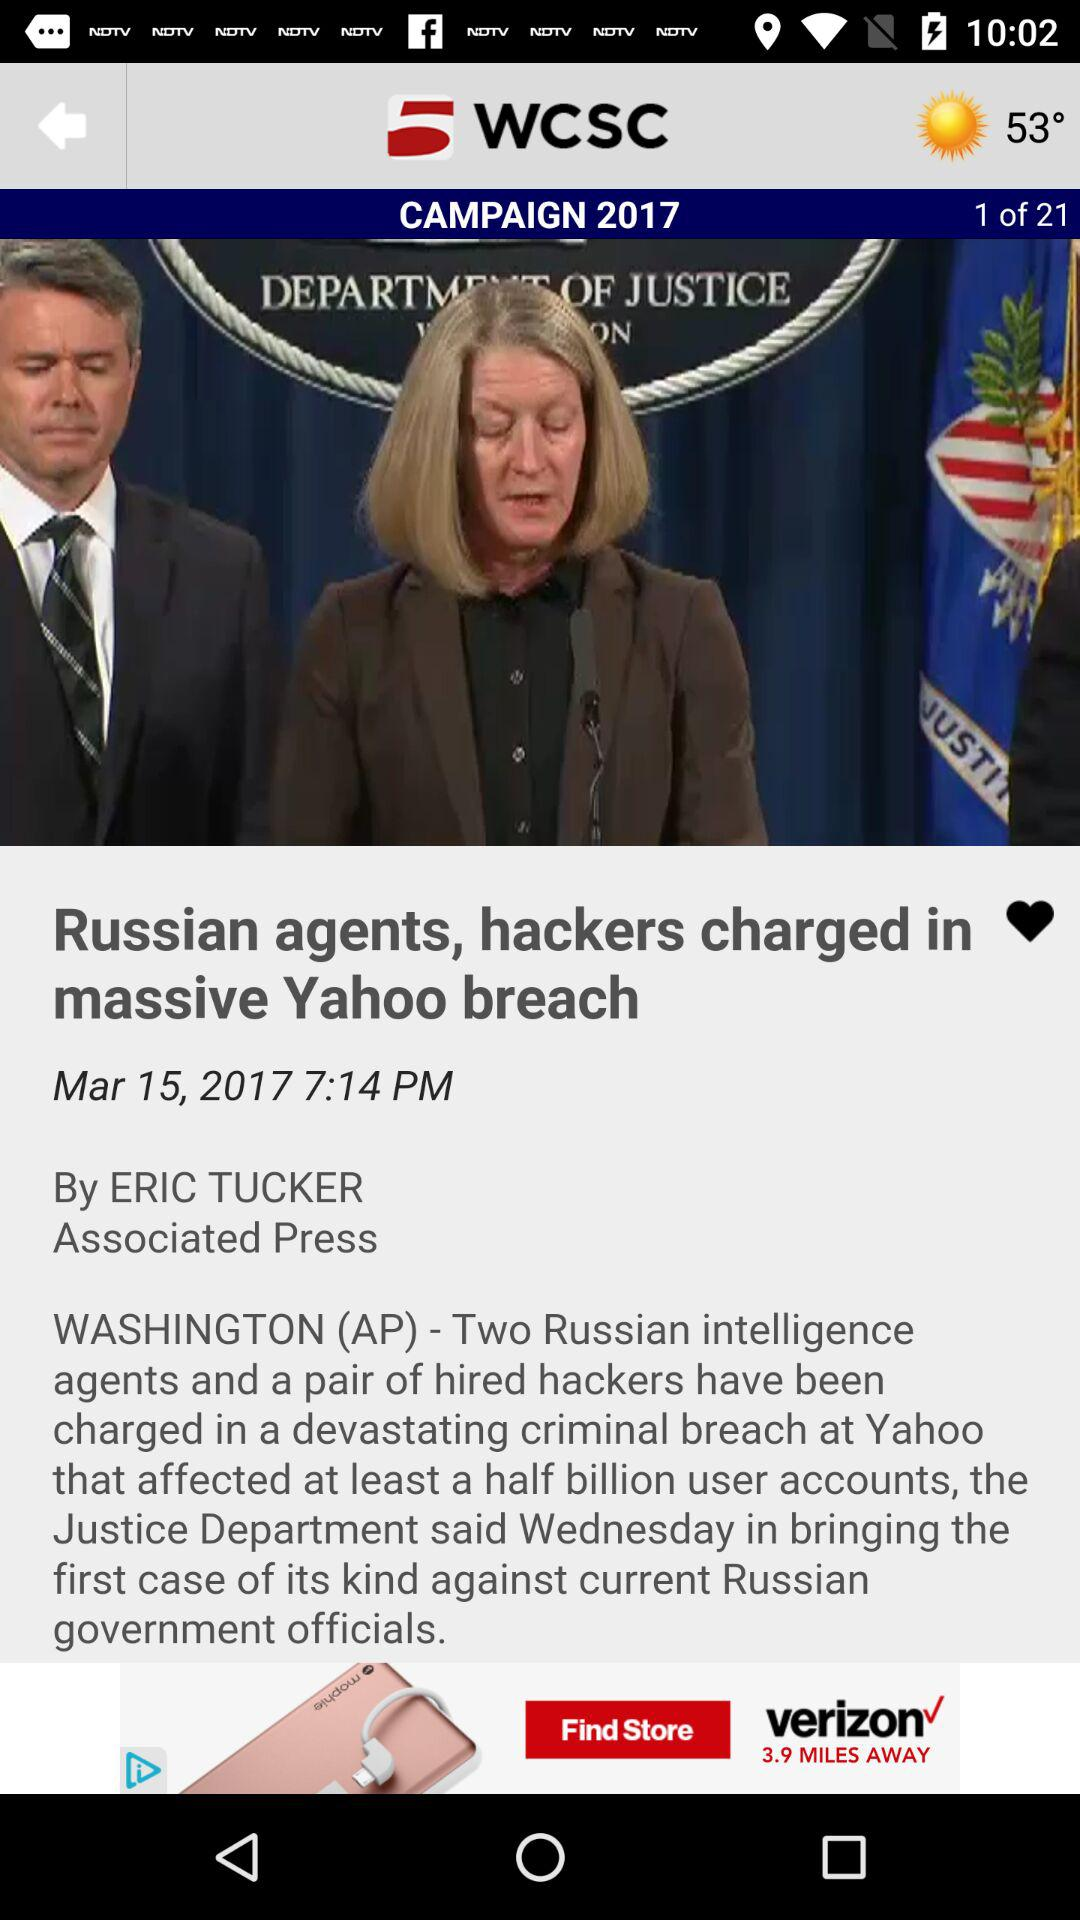Who posted the news about the "Russian agents, hackers charged in the massive Yahoo breach"? The news was posted by Eric Tucker. 